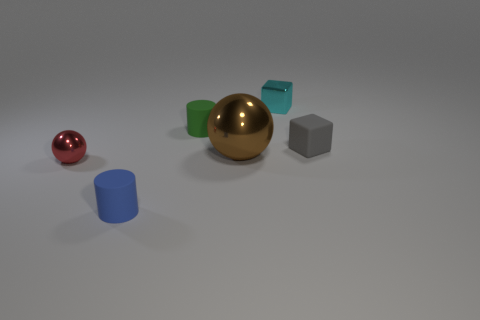Are there any other things that have the same shape as the green thing?
Offer a very short reply. Yes. Is there anything else that has the same size as the gray cube?
Your answer should be very brief. Yes. How many gray matte objects have the same shape as the cyan shiny thing?
Offer a very short reply. 1. What is the size of the brown thing that is made of the same material as the small red object?
Your response must be concise. Large. Are there more brown objects than tiny cubes?
Your answer should be compact. No. What color is the tiny shiny thing that is left of the brown metal thing?
Keep it short and to the point. Red. There is a rubber object that is to the left of the cyan object and behind the small red thing; what is its size?
Offer a terse response. Small. What number of cylinders are the same size as the metal block?
Provide a succinct answer. 2. There is another object that is the same shape as the red thing; what material is it?
Your response must be concise. Metal. Is the big shiny thing the same shape as the red shiny thing?
Keep it short and to the point. Yes. 